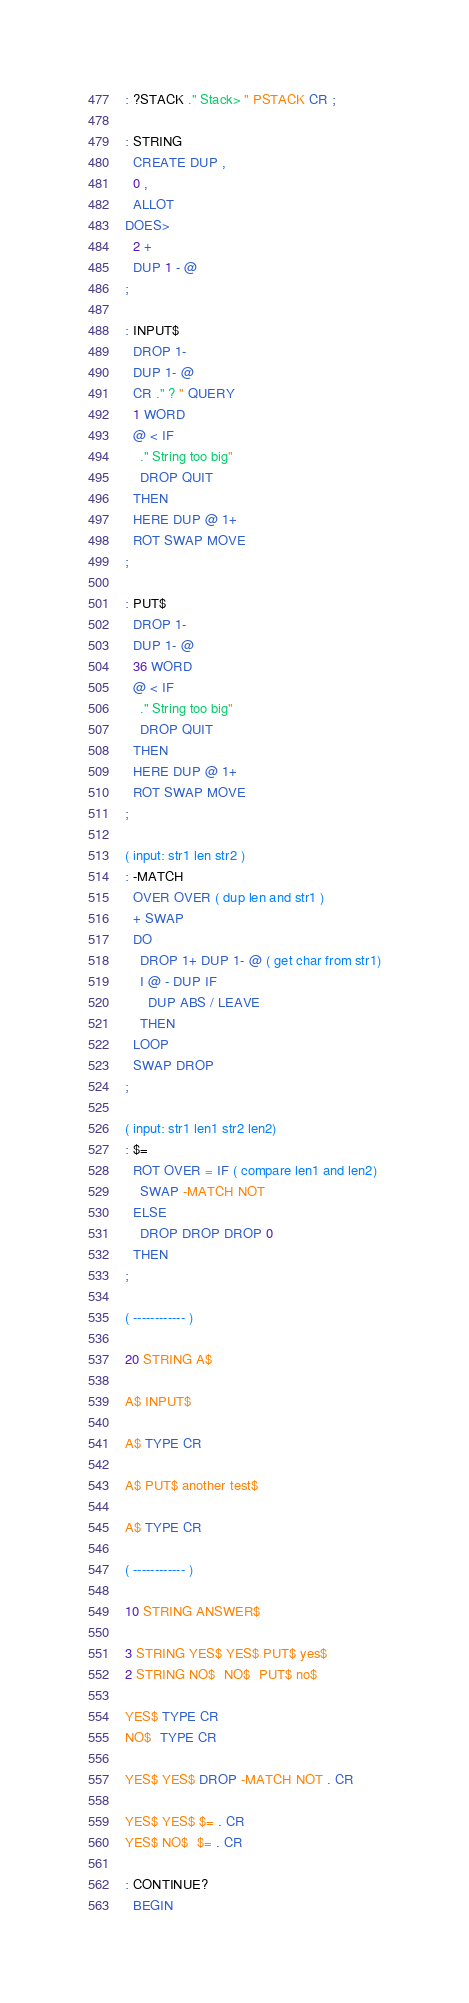<code> <loc_0><loc_0><loc_500><loc_500><_Forth_>: ?STACK ." Stack> " PSTACK CR ;

: STRING
  CREATE DUP ,
  0 ,
  ALLOT
DOES>
  2 +
  DUP 1 - @
;

: INPUT$
  DROP 1-
  DUP 1- @
  CR ." ? " QUERY
  1 WORD
  @ < IF
    ." String too big"
    DROP QUIT
  THEN
  HERE DUP @ 1+
  ROT SWAP MOVE
;

: PUT$
  DROP 1-
  DUP 1- @
  36 WORD
  @ < IF
    ." String too big"
    DROP QUIT
  THEN
  HERE DUP @ 1+
  ROT SWAP MOVE
;

( input: str1 len str2 )
: -MATCH
  OVER OVER ( dup len and str1 )
  + SWAP
  DO
    DROP 1+ DUP 1- @ ( get char from str1)
    I @ - DUP IF
      DUP ABS / LEAVE
    THEN
  LOOP
  SWAP DROP
;

( input: str1 len1 str2 len2)
: $=
  ROT OVER = IF ( compare len1 and len2)
    SWAP -MATCH NOT
  ELSE
    DROP DROP DROP 0
  THEN
;

( ------------ )

20 STRING A$

A$ INPUT$

A$ TYPE CR

A$ PUT$ another test$

A$ TYPE CR

( ------------ )

10 STRING ANSWER$

3 STRING YES$ YES$ PUT$ yes$
2 STRING NO$  NO$  PUT$ no$

YES$ TYPE CR
NO$  TYPE CR

YES$ YES$ DROP -MATCH NOT . CR

YES$ YES$ $= . CR
YES$ NO$  $= . CR

: CONTINUE?
  BEGIN</code> 